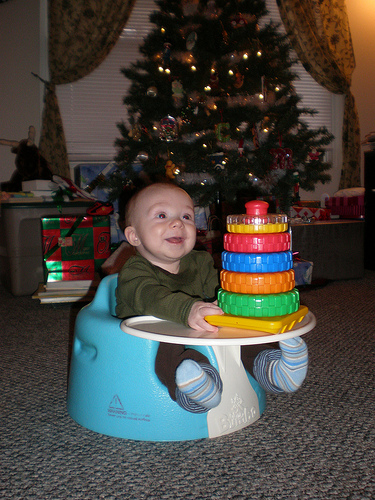<image>
Can you confirm if the child is on the christmas tree? No. The child is not positioned on the christmas tree. They may be near each other, but the child is not supported by or resting on top of the christmas tree. Where is the baby in relation to the christmas tree? Is it on the christmas tree? No. The baby is not positioned on the christmas tree. They may be near each other, but the baby is not supported by or resting on top of the christmas tree. 